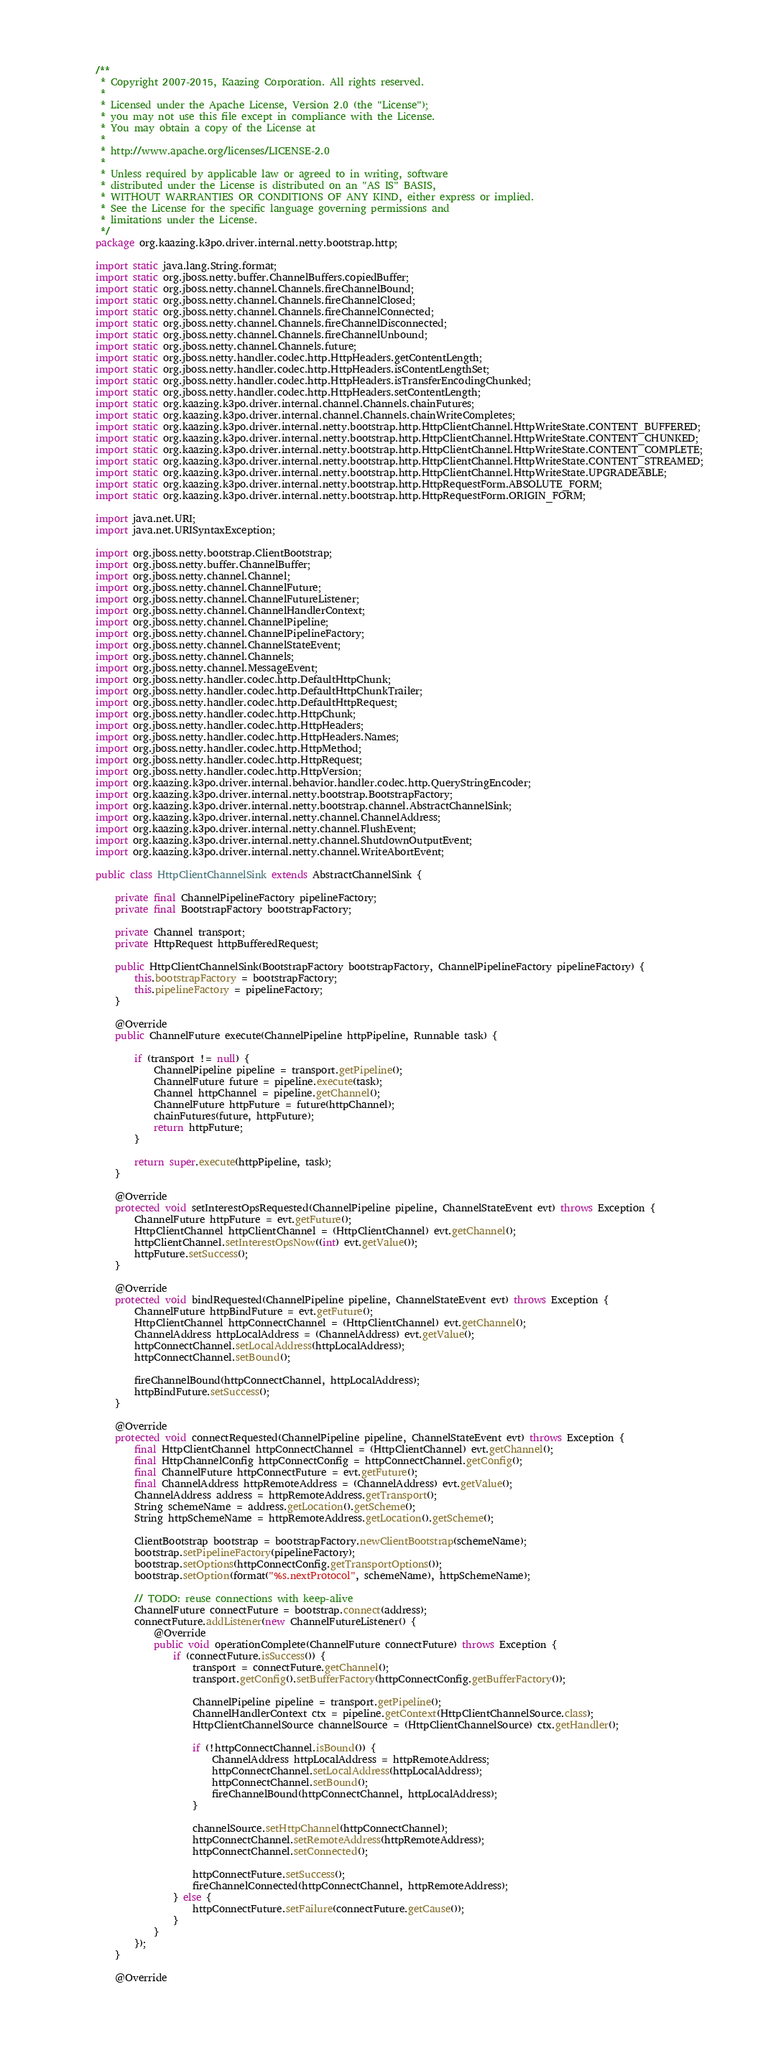<code> <loc_0><loc_0><loc_500><loc_500><_Java_>/**
 * Copyright 2007-2015, Kaazing Corporation. All rights reserved.
 *
 * Licensed under the Apache License, Version 2.0 (the "License");
 * you may not use this file except in compliance with the License.
 * You may obtain a copy of the License at
 *
 * http://www.apache.org/licenses/LICENSE-2.0
 *
 * Unless required by applicable law or agreed to in writing, software
 * distributed under the License is distributed on an "AS IS" BASIS,
 * WITHOUT WARRANTIES OR CONDITIONS OF ANY KIND, either express or implied.
 * See the License for the specific language governing permissions and
 * limitations under the License.
 */
package org.kaazing.k3po.driver.internal.netty.bootstrap.http;

import static java.lang.String.format;
import static org.jboss.netty.buffer.ChannelBuffers.copiedBuffer;
import static org.jboss.netty.channel.Channels.fireChannelBound;
import static org.jboss.netty.channel.Channels.fireChannelClosed;
import static org.jboss.netty.channel.Channels.fireChannelConnected;
import static org.jboss.netty.channel.Channels.fireChannelDisconnected;
import static org.jboss.netty.channel.Channels.fireChannelUnbound;
import static org.jboss.netty.channel.Channels.future;
import static org.jboss.netty.handler.codec.http.HttpHeaders.getContentLength;
import static org.jboss.netty.handler.codec.http.HttpHeaders.isContentLengthSet;
import static org.jboss.netty.handler.codec.http.HttpHeaders.isTransferEncodingChunked;
import static org.jboss.netty.handler.codec.http.HttpHeaders.setContentLength;
import static org.kaazing.k3po.driver.internal.channel.Channels.chainFutures;
import static org.kaazing.k3po.driver.internal.channel.Channels.chainWriteCompletes;
import static org.kaazing.k3po.driver.internal.netty.bootstrap.http.HttpClientChannel.HttpWriteState.CONTENT_BUFFERED;
import static org.kaazing.k3po.driver.internal.netty.bootstrap.http.HttpClientChannel.HttpWriteState.CONTENT_CHUNKED;
import static org.kaazing.k3po.driver.internal.netty.bootstrap.http.HttpClientChannel.HttpWriteState.CONTENT_COMPLETE;
import static org.kaazing.k3po.driver.internal.netty.bootstrap.http.HttpClientChannel.HttpWriteState.CONTENT_STREAMED;
import static org.kaazing.k3po.driver.internal.netty.bootstrap.http.HttpClientChannel.HttpWriteState.UPGRADEABLE;
import static org.kaazing.k3po.driver.internal.netty.bootstrap.http.HttpRequestForm.ABSOLUTE_FORM;
import static org.kaazing.k3po.driver.internal.netty.bootstrap.http.HttpRequestForm.ORIGIN_FORM;

import java.net.URI;
import java.net.URISyntaxException;

import org.jboss.netty.bootstrap.ClientBootstrap;
import org.jboss.netty.buffer.ChannelBuffer;
import org.jboss.netty.channel.Channel;
import org.jboss.netty.channel.ChannelFuture;
import org.jboss.netty.channel.ChannelFutureListener;
import org.jboss.netty.channel.ChannelHandlerContext;
import org.jboss.netty.channel.ChannelPipeline;
import org.jboss.netty.channel.ChannelPipelineFactory;
import org.jboss.netty.channel.ChannelStateEvent;
import org.jboss.netty.channel.Channels;
import org.jboss.netty.channel.MessageEvent;
import org.jboss.netty.handler.codec.http.DefaultHttpChunk;
import org.jboss.netty.handler.codec.http.DefaultHttpChunkTrailer;
import org.jboss.netty.handler.codec.http.DefaultHttpRequest;
import org.jboss.netty.handler.codec.http.HttpChunk;
import org.jboss.netty.handler.codec.http.HttpHeaders;
import org.jboss.netty.handler.codec.http.HttpHeaders.Names;
import org.jboss.netty.handler.codec.http.HttpMethod;
import org.jboss.netty.handler.codec.http.HttpRequest;
import org.jboss.netty.handler.codec.http.HttpVersion;
import org.kaazing.k3po.driver.internal.behavior.handler.codec.http.QueryStringEncoder;
import org.kaazing.k3po.driver.internal.netty.bootstrap.BootstrapFactory;
import org.kaazing.k3po.driver.internal.netty.bootstrap.channel.AbstractChannelSink;
import org.kaazing.k3po.driver.internal.netty.channel.ChannelAddress;
import org.kaazing.k3po.driver.internal.netty.channel.FlushEvent;
import org.kaazing.k3po.driver.internal.netty.channel.ShutdownOutputEvent;
import org.kaazing.k3po.driver.internal.netty.channel.WriteAbortEvent;

public class HttpClientChannelSink extends AbstractChannelSink {

    private final ChannelPipelineFactory pipelineFactory;
    private final BootstrapFactory bootstrapFactory;

    private Channel transport;
    private HttpRequest httpBufferedRequest;

    public HttpClientChannelSink(BootstrapFactory bootstrapFactory, ChannelPipelineFactory pipelineFactory) {
        this.bootstrapFactory = bootstrapFactory;
        this.pipelineFactory = pipelineFactory;
    }

    @Override
    public ChannelFuture execute(ChannelPipeline httpPipeline, Runnable task) {

        if (transport != null) {
            ChannelPipeline pipeline = transport.getPipeline();
            ChannelFuture future = pipeline.execute(task);
            Channel httpChannel = pipeline.getChannel();
            ChannelFuture httpFuture = future(httpChannel);
            chainFutures(future, httpFuture);
            return httpFuture;
        }

        return super.execute(httpPipeline, task);
    }

    @Override
    protected void setInterestOpsRequested(ChannelPipeline pipeline, ChannelStateEvent evt) throws Exception {
        ChannelFuture httpFuture = evt.getFuture();
        HttpClientChannel httpClientChannel = (HttpClientChannel) evt.getChannel();
        httpClientChannel.setInterestOpsNow((int) evt.getValue());
        httpFuture.setSuccess();
    }

    @Override
    protected void bindRequested(ChannelPipeline pipeline, ChannelStateEvent evt) throws Exception {
        ChannelFuture httpBindFuture = evt.getFuture();
        HttpClientChannel httpConnectChannel = (HttpClientChannel) evt.getChannel();
        ChannelAddress httpLocalAddress = (ChannelAddress) evt.getValue();
        httpConnectChannel.setLocalAddress(httpLocalAddress);
        httpConnectChannel.setBound();

        fireChannelBound(httpConnectChannel, httpLocalAddress);
        httpBindFuture.setSuccess();
    }

    @Override
    protected void connectRequested(ChannelPipeline pipeline, ChannelStateEvent evt) throws Exception {
        final HttpClientChannel httpConnectChannel = (HttpClientChannel) evt.getChannel();
        final HttpChannelConfig httpConnectConfig = httpConnectChannel.getConfig();
        final ChannelFuture httpConnectFuture = evt.getFuture();
        final ChannelAddress httpRemoteAddress = (ChannelAddress) evt.getValue();
        ChannelAddress address = httpRemoteAddress.getTransport();
        String schemeName = address.getLocation().getScheme();
        String httpSchemeName = httpRemoteAddress.getLocation().getScheme();

        ClientBootstrap bootstrap = bootstrapFactory.newClientBootstrap(schemeName);
        bootstrap.setPipelineFactory(pipelineFactory);
        bootstrap.setOptions(httpConnectConfig.getTransportOptions());
        bootstrap.setOption(format("%s.nextProtocol", schemeName), httpSchemeName);

        // TODO: reuse connections with keep-alive
        ChannelFuture connectFuture = bootstrap.connect(address);
        connectFuture.addListener(new ChannelFutureListener() {
            @Override
            public void operationComplete(ChannelFuture connectFuture) throws Exception {
                if (connectFuture.isSuccess()) {
                    transport = connectFuture.getChannel();
                    transport.getConfig().setBufferFactory(httpConnectConfig.getBufferFactory());

                    ChannelPipeline pipeline = transport.getPipeline();
                    ChannelHandlerContext ctx = pipeline.getContext(HttpClientChannelSource.class);
                    HttpClientChannelSource channelSource = (HttpClientChannelSource) ctx.getHandler();

                    if (!httpConnectChannel.isBound()) {
                        ChannelAddress httpLocalAddress = httpRemoteAddress;
                        httpConnectChannel.setLocalAddress(httpLocalAddress);
                        httpConnectChannel.setBound();
                        fireChannelBound(httpConnectChannel, httpLocalAddress);
                    }

                    channelSource.setHttpChannel(httpConnectChannel);
                    httpConnectChannel.setRemoteAddress(httpRemoteAddress);
                    httpConnectChannel.setConnected();

                    httpConnectFuture.setSuccess();
                    fireChannelConnected(httpConnectChannel, httpRemoteAddress);
                } else {
                    httpConnectFuture.setFailure(connectFuture.getCause());
                }
            }
        });
    }

    @Override</code> 